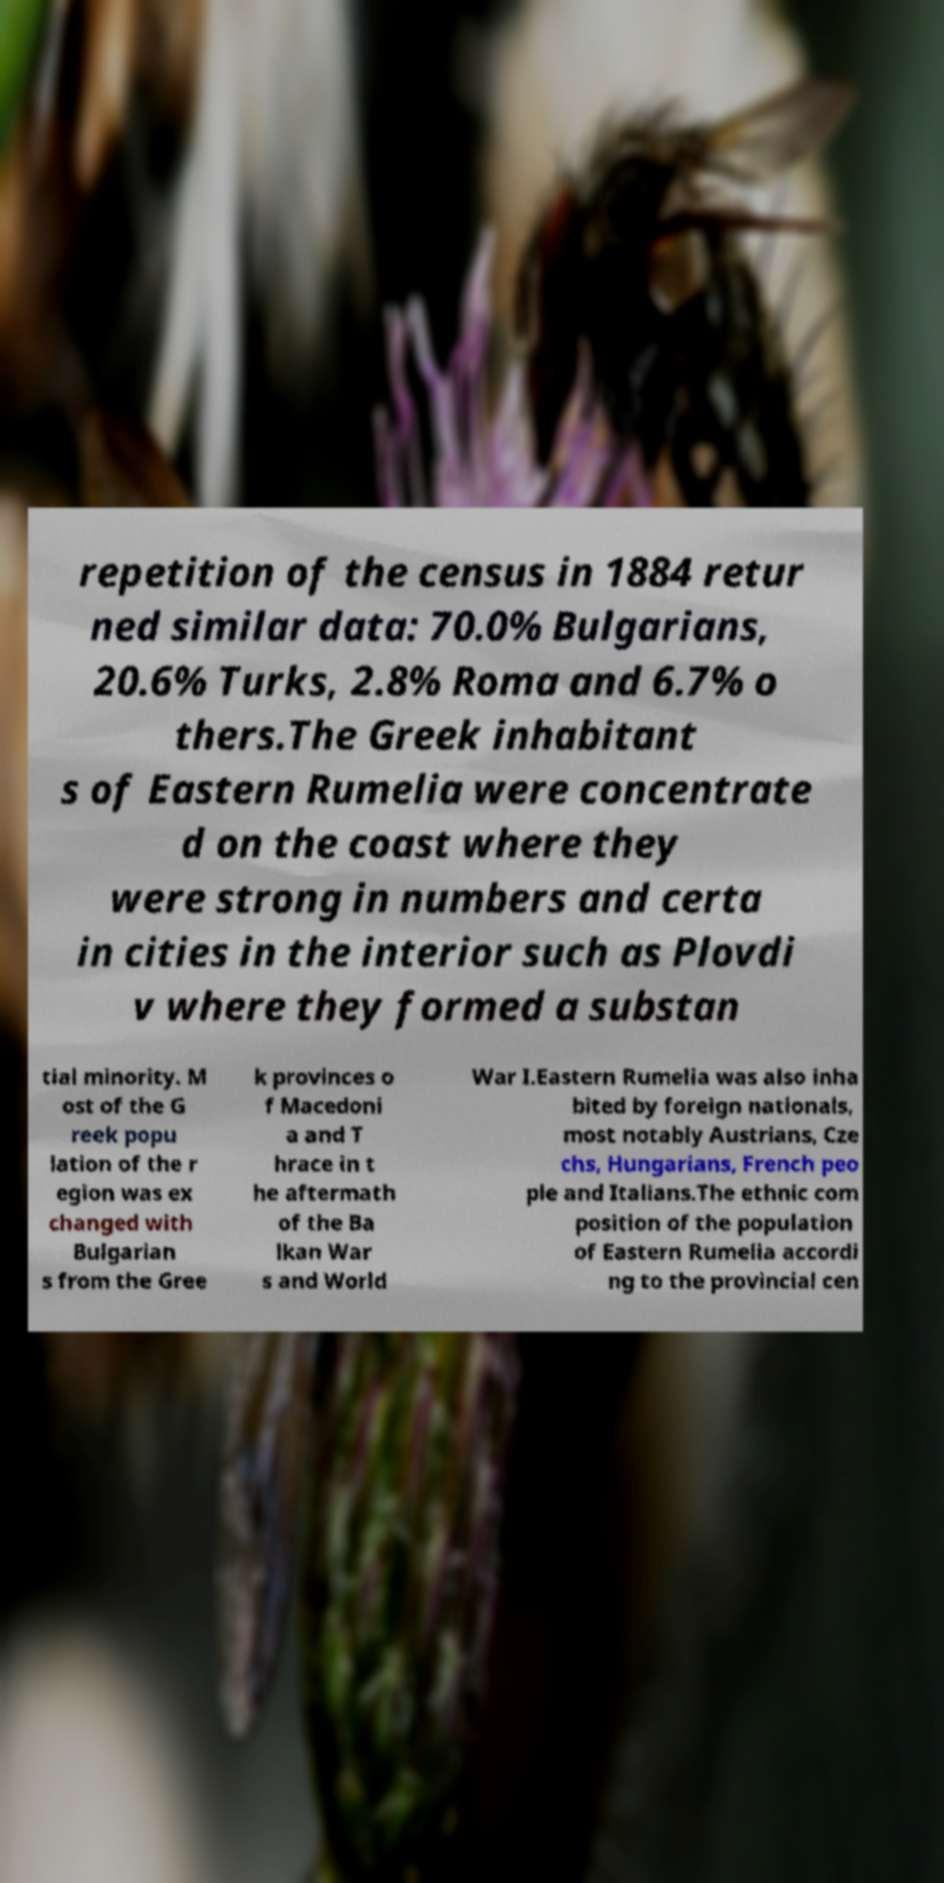I need the written content from this picture converted into text. Can you do that? repetition of the census in 1884 retur ned similar data: 70.0% Bulgarians, 20.6% Turks, 2.8% Roma and 6.7% o thers.The Greek inhabitant s of Eastern Rumelia were concentrate d on the coast where they were strong in numbers and certa in cities in the interior such as Plovdi v where they formed a substan tial minority. M ost of the G reek popu lation of the r egion was ex changed with Bulgarian s from the Gree k provinces o f Macedoni a and T hrace in t he aftermath of the Ba lkan War s and World War I.Eastern Rumelia was also inha bited by foreign nationals, most notably Austrians, Cze chs, Hungarians, French peo ple and Italians.The ethnic com position of the population of Eastern Rumelia accordi ng to the provincial cen 